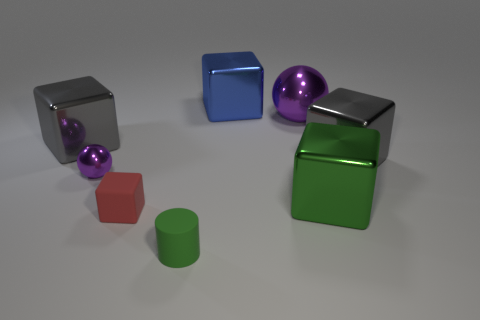Subtract all small blocks. How many blocks are left? 4 Add 1 green things. How many objects exist? 9 Subtract all gray cylinders. How many gray blocks are left? 2 Subtract all green cubes. How many cubes are left? 4 Subtract 2 blocks. How many blocks are left? 3 Subtract all yellow cubes. Subtract all cyan cylinders. How many cubes are left? 5 Subtract 2 purple balls. How many objects are left? 6 Subtract all cylinders. How many objects are left? 7 Subtract all red rubber blocks. Subtract all tiny matte cubes. How many objects are left? 6 Add 7 large blue metal blocks. How many large blue metal blocks are left? 8 